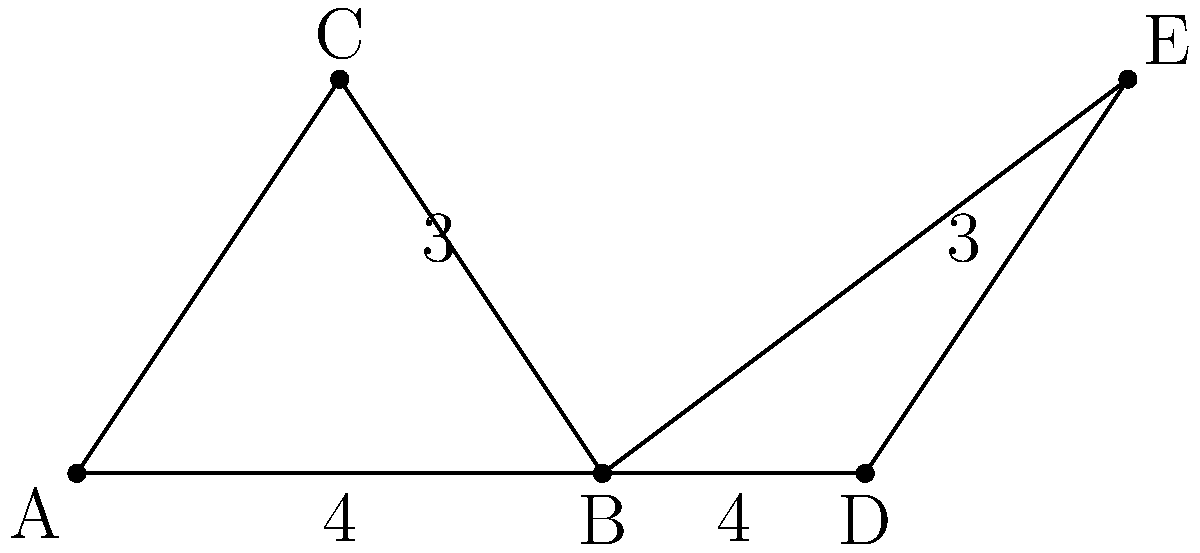In designing a geometry-based puzzle game interface, you've created two triangles as shown in the diagram. Triangle ABC and triangle BDE share a common base angle at point B. Given that AB = BD = 4 units and BC = DE = 3 units, how would you prove that these triangles are congruent to ensure consistent game mechanics? To prove that triangles ABC and BDE are congruent, we can use the Side-Angle-Side (SAS) congruence theorem. Here's the step-by-step proof:

1. Given information:
   - AB = BD = 4 units
   - BC = DE = 3 units
   - Angle B is common to both triangles

2. Side (S): AB = BD
   We know that AB and BD are both equal to 4 units.

3. Angle (A): Angle ABC = Angle DBE
   The angle at B is shared by both triangles, so it's the same for both.

4. Side (S): BC = DE
   We're given that BC and DE are both equal to 3 units.

5. Apply the SAS congruence theorem:
   When two triangles have two corresponding sides equal and the included angle equal, the triangles are congruent.

6. Conclusion:
   Since we have shown that AB = BD, BC = DE, and angle B is common to both triangles, we can conclude that triangle ABC is congruent to triangle BDE by the SAS congruence theorem.

This proof ensures that the game mechanics will be consistent for both triangles in the puzzle interface, providing a fair and logical experience for the player.
Answer: SAS congruence theorem 